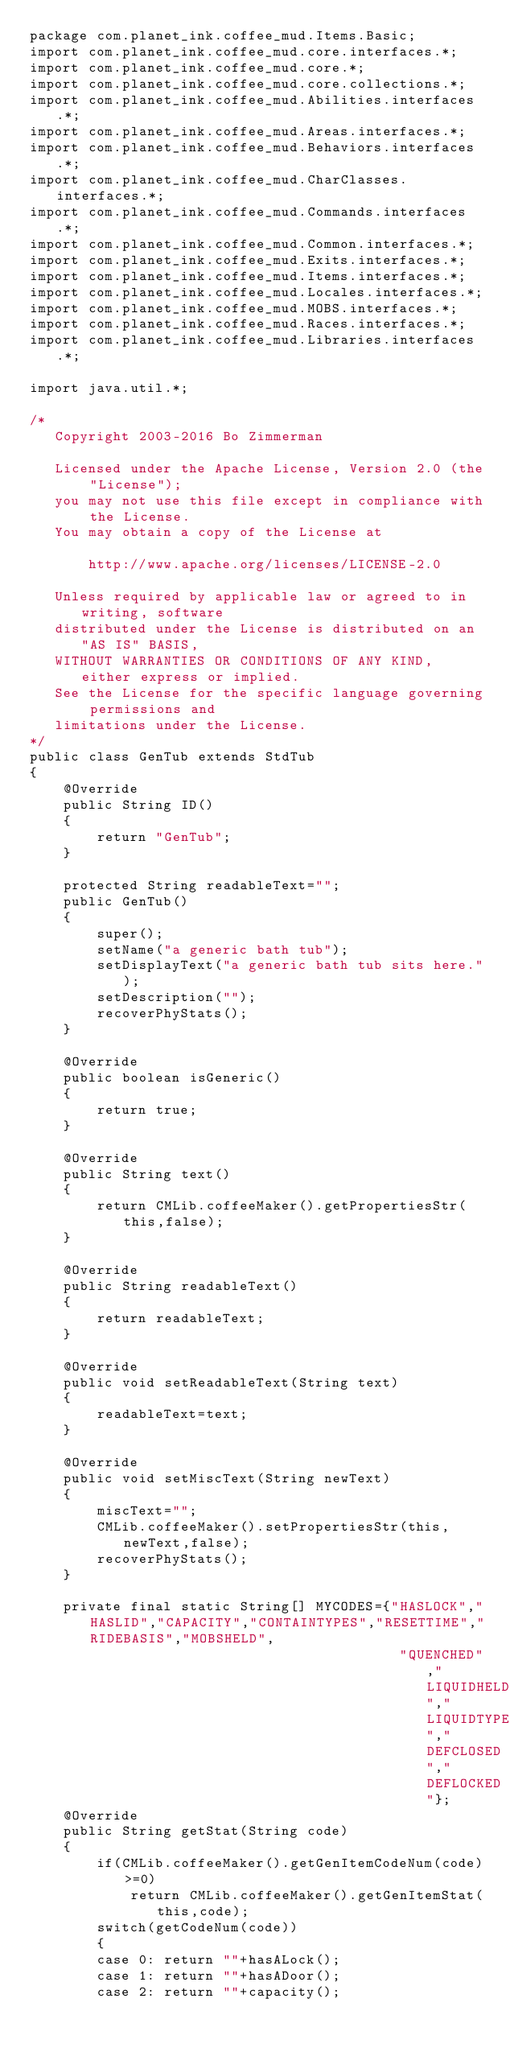Convert code to text. <code><loc_0><loc_0><loc_500><loc_500><_Java_>package com.planet_ink.coffee_mud.Items.Basic;
import com.planet_ink.coffee_mud.core.interfaces.*;
import com.planet_ink.coffee_mud.core.*;
import com.planet_ink.coffee_mud.core.collections.*;
import com.planet_ink.coffee_mud.Abilities.interfaces.*;
import com.planet_ink.coffee_mud.Areas.interfaces.*;
import com.planet_ink.coffee_mud.Behaviors.interfaces.*;
import com.planet_ink.coffee_mud.CharClasses.interfaces.*;
import com.planet_ink.coffee_mud.Commands.interfaces.*;
import com.planet_ink.coffee_mud.Common.interfaces.*;
import com.planet_ink.coffee_mud.Exits.interfaces.*;
import com.planet_ink.coffee_mud.Items.interfaces.*;
import com.planet_ink.coffee_mud.Locales.interfaces.*;
import com.planet_ink.coffee_mud.MOBS.interfaces.*;
import com.planet_ink.coffee_mud.Races.interfaces.*;
import com.planet_ink.coffee_mud.Libraries.interfaces.*;

import java.util.*;

/*
   Copyright 2003-2016 Bo Zimmerman

   Licensed under the Apache License, Version 2.0 (the "License");
   you may not use this file except in compliance with the License.
   You may obtain a copy of the License at

	   http://www.apache.org/licenses/LICENSE-2.0

   Unless required by applicable law or agreed to in writing, software
   distributed under the License is distributed on an "AS IS" BASIS,
   WITHOUT WARRANTIES OR CONDITIONS OF ANY KIND, either express or implied.
   See the License for the specific language governing permissions and
   limitations under the License.
*/
public class GenTub extends StdTub
{
	@Override
	public String ID()
	{
		return "GenTub";
	}

	protected String readableText="";
	public GenTub()
	{
		super();
		setName("a generic bath tub");
		setDisplayText("a generic bath tub sits here.");
		setDescription("");
		recoverPhyStats();
	}

	@Override
	public boolean isGeneric()
	{
		return true;
	}

	@Override
	public String text()
	{
		return CMLib.coffeeMaker().getPropertiesStr(this,false);
	}

	@Override
	public String readableText()
	{
		return readableText;
	}

	@Override
	public void setReadableText(String text)
	{
		readableText=text;
	}

	@Override
	public void setMiscText(String newText)
	{
		miscText="";
		CMLib.coffeeMaker().setPropertiesStr(this,newText,false);
		recoverPhyStats();
	}

	private final static String[] MYCODES={"HASLOCK","HASLID","CAPACITY","CONTAINTYPES","RESETTIME","RIDEBASIS","MOBSHELD",
											"QUENCHED","LIQUIDHELD","LIQUIDTYPE","DEFCLOSED","DEFLOCKED"};
	@Override
	public String getStat(String code)
	{
		if(CMLib.coffeeMaker().getGenItemCodeNum(code)>=0)
			return CMLib.coffeeMaker().getGenItemStat(this,code);
		switch(getCodeNum(code))
		{
		case 0: return ""+hasALock();
		case 1: return ""+hasADoor();
		case 2: return ""+capacity();</code> 